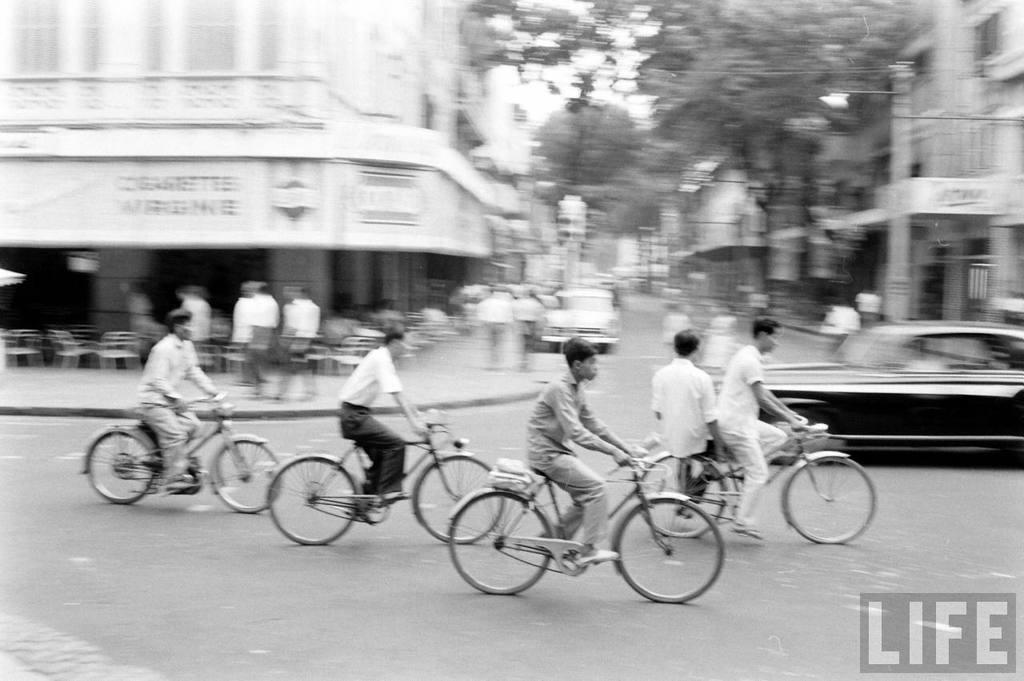Describe this image in one or two sentences. This image is clicked outside on the roads. There are many people in this image. In the front, five persons are riding bicycle. In the background there is a building, trees and a car. To the right, there is a car in black color. 